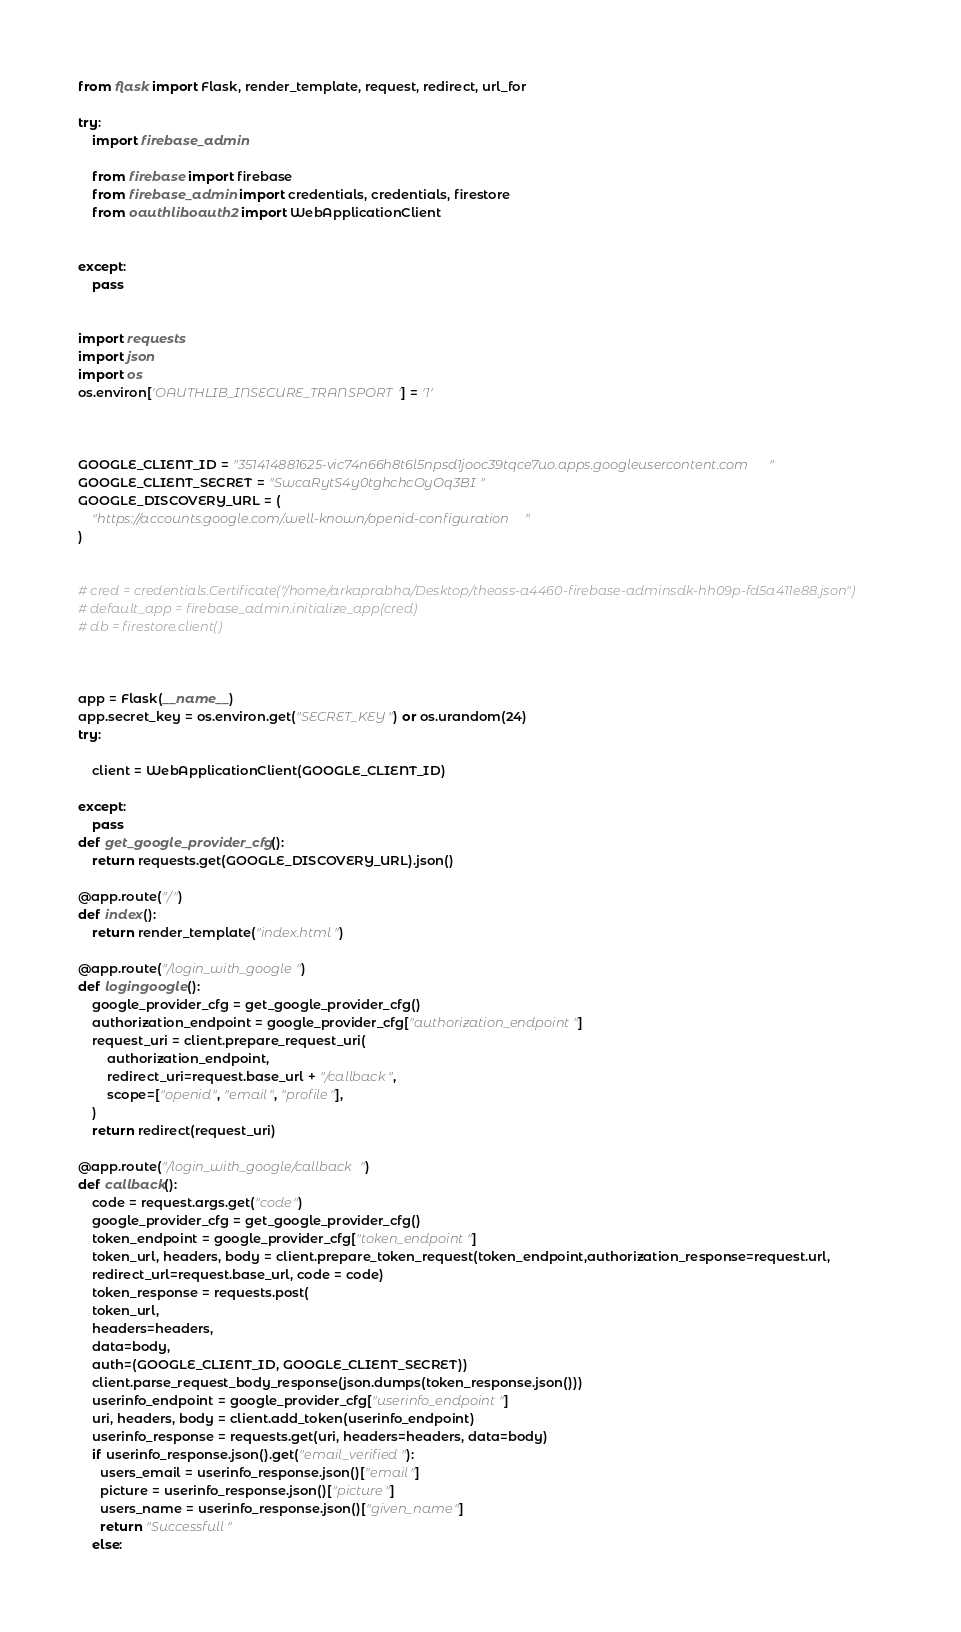<code> <loc_0><loc_0><loc_500><loc_500><_Python_>
from flask import Flask, render_template, request, redirect, url_for

try:
    import firebase_admin

    from firebase import firebase
    from firebase_admin import credentials, credentials, firestore
    from oauthlib.oauth2 import WebApplicationClient


except:
    pass


import requests
import json
import os
os.environ['OAUTHLIB_INSECURE_TRANSPORT'] = '1'



GOOGLE_CLIENT_ID = "351414881625-vic74n66h8t6l5npsd1jooc39tqce7uo.apps.googleusercontent.com"
GOOGLE_CLIENT_SECRET = "SwcaRytS4y0tghchcOyOq3BI"
GOOGLE_DISCOVERY_URL = (
    "https://accounts.google.com/.well-known/openid-configuration"
)


# cred = credentials.Certificate("/home/arkaprabha/Desktop/theoss-a4460-firebase-adminsdk-hh09p-fd5a411e88.json")
# default_app = firebase_admin.initialize_app(cred)
# db = firestore.client()



app = Flask(__name__)
app.secret_key = os.environ.get("SECRET_KEY") or os.urandom(24)
try:

    client = WebApplicationClient(GOOGLE_CLIENT_ID)

except:
    pass
def get_google_provider_cfg():
    return requests.get(GOOGLE_DISCOVERY_URL).json()

@app.route("/")
def index():
    return render_template("index.html")

@app.route("/login_with_google")
def logingoogle():
    google_provider_cfg = get_google_provider_cfg()
    authorization_endpoint = google_provider_cfg["authorization_endpoint"]
    request_uri = client.prepare_request_uri(
        authorization_endpoint,
        redirect_uri=request.base_url + "/callback",
        scope=["openid", "email", "profile"],
    )
    return redirect(request_uri)

@app.route("/login_with_google/callback")
def callback():
    code = request.args.get("code")
    google_provider_cfg = get_google_provider_cfg()
    token_endpoint = google_provider_cfg["token_endpoint"]
    token_url, headers, body = client.prepare_token_request(token_endpoint,authorization_response=request.url,
    redirect_url=request.base_url, code = code)
    token_response = requests.post(
    token_url,
    headers=headers,
    data=body,
    auth=(GOOGLE_CLIENT_ID, GOOGLE_CLIENT_SECRET))
    client.parse_request_body_response(json.dumps(token_response.json()))
    userinfo_endpoint = google_provider_cfg["userinfo_endpoint"]
    uri, headers, body = client.add_token(userinfo_endpoint)
    userinfo_response = requests.get(uri, headers=headers, data=body)
    if userinfo_response.json().get("email_verified"):
      users_email = userinfo_response.json()["email"]
      picture = userinfo_response.json()["picture"]
      users_name = userinfo_response.json()["given_name"]
      return "Successfull"
    else:</code> 